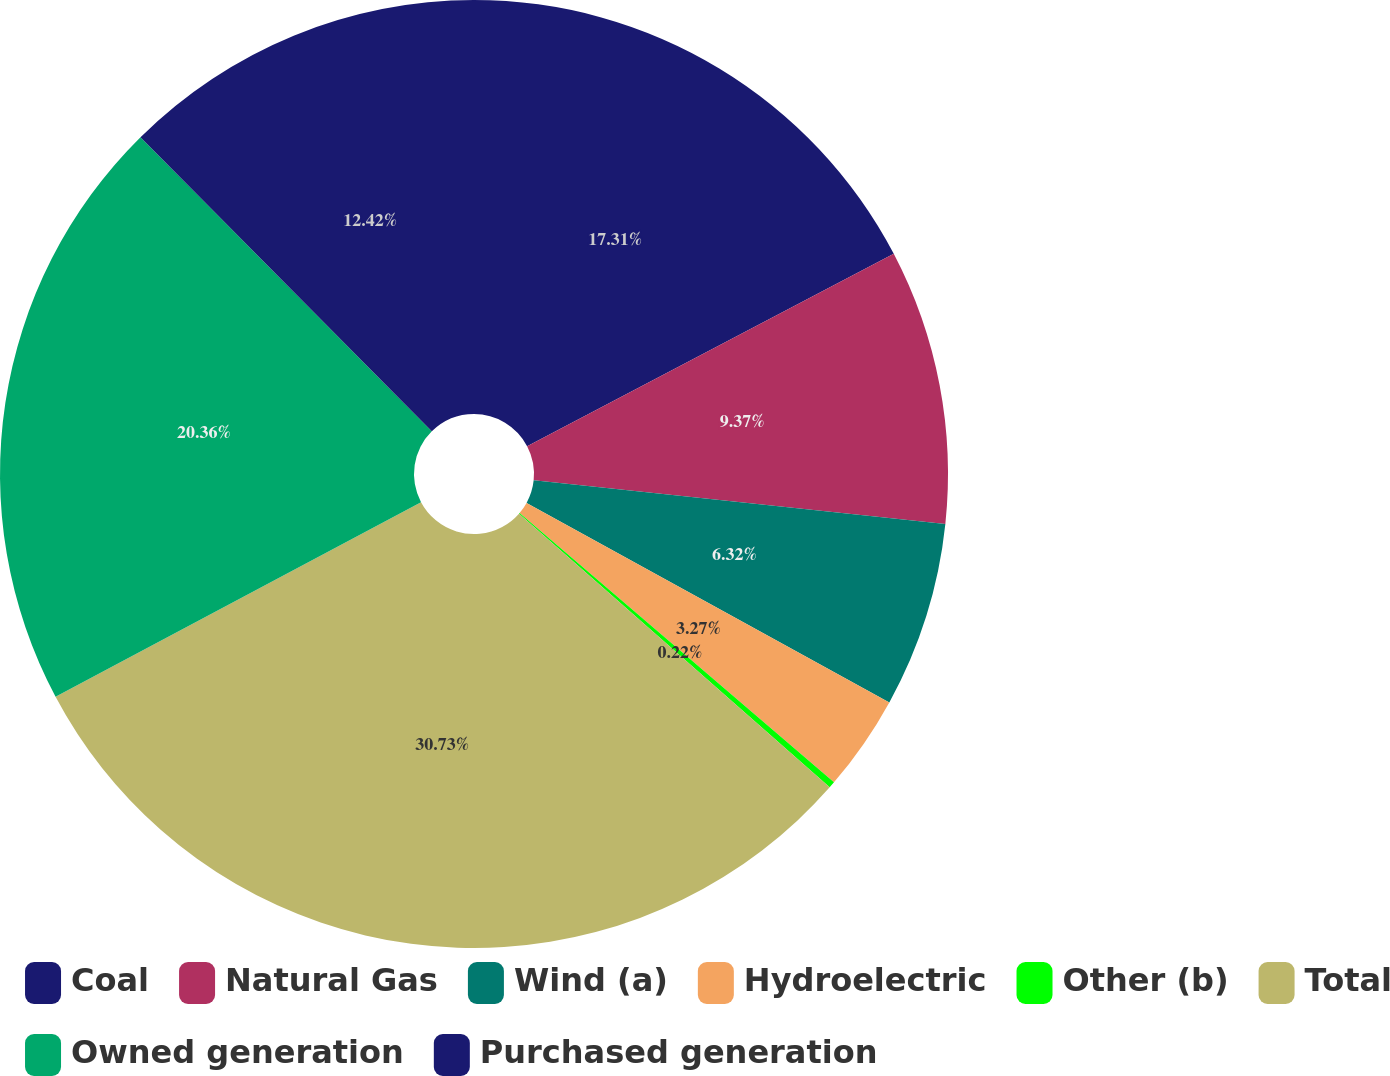Convert chart to OTSL. <chart><loc_0><loc_0><loc_500><loc_500><pie_chart><fcel>Coal<fcel>Natural Gas<fcel>Wind (a)<fcel>Hydroelectric<fcel>Other (b)<fcel>Total<fcel>Owned generation<fcel>Purchased generation<nl><fcel>17.31%<fcel>9.37%<fcel>6.32%<fcel>3.27%<fcel>0.22%<fcel>30.72%<fcel>20.36%<fcel>12.42%<nl></chart> 